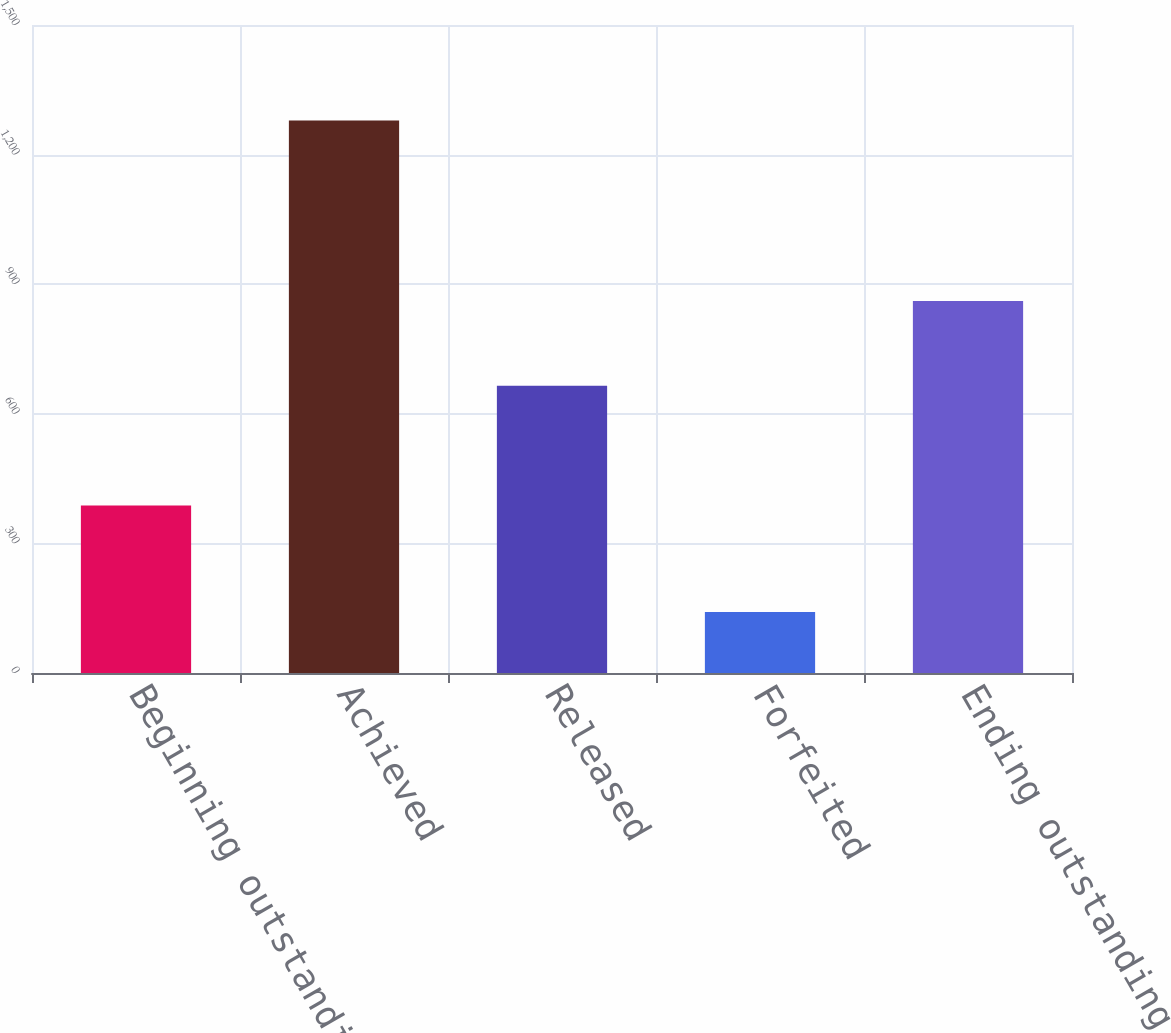<chart> <loc_0><loc_0><loc_500><loc_500><bar_chart><fcel>Beginning outstanding balance<fcel>Achieved<fcel>Released<fcel>Forfeited<fcel>Ending outstanding balance<nl><fcel>388<fcel>1279<fcel>665<fcel>141<fcel>861<nl></chart> 